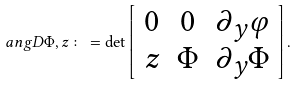<formula> <loc_0><loc_0><loc_500><loc_500>\ a n g { D \Phi , z } \colon = \det \left [ \begin{array} { c c c } 0 & 0 & \partial _ { y } \varphi \\ z & \Phi & \partial _ { y } \Phi \end{array} \right ] .</formula> 